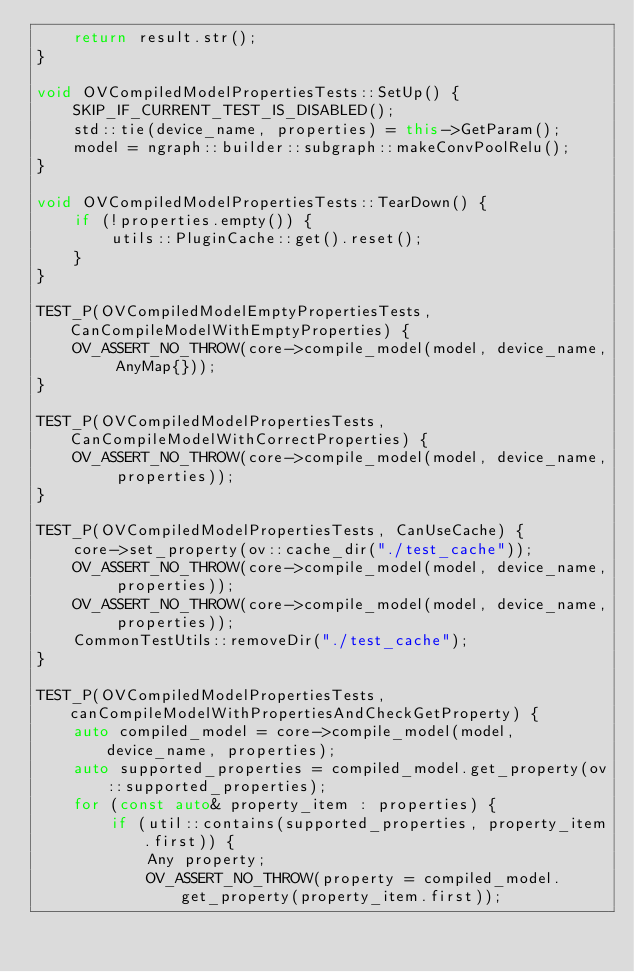Convert code to text. <code><loc_0><loc_0><loc_500><loc_500><_C++_>    return result.str();
}

void OVCompiledModelPropertiesTests::SetUp() {
    SKIP_IF_CURRENT_TEST_IS_DISABLED();
    std::tie(device_name, properties) = this->GetParam();
    model = ngraph::builder::subgraph::makeConvPoolRelu();
}

void OVCompiledModelPropertiesTests::TearDown() {
    if (!properties.empty()) {
        utils::PluginCache::get().reset();
    }
}

TEST_P(OVCompiledModelEmptyPropertiesTests, CanCompileModelWithEmptyProperties) {
    OV_ASSERT_NO_THROW(core->compile_model(model, device_name, AnyMap{}));
}

TEST_P(OVCompiledModelPropertiesTests, CanCompileModelWithCorrectProperties) {
    OV_ASSERT_NO_THROW(core->compile_model(model, device_name, properties));
}

TEST_P(OVCompiledModelPropertiesTests, CanUseCache) {
    core->set_property(ov::cache_dir("./test_cache"));
    OV_ASSERT_NO_THROW(core->compile_model(model, device_name, properties));
    OV_ASSERT_NO_THROW(core->compile_model(model, device_name, properties));
    CommonTestUtils::removeDir("./test_cache");
}

TEST_P(OVCompiledModelPropertiesTests, canCompileModelWithPropertiesAndCheckGetProperty) {
    auto compiled_model = core->compile_model(model, device_name, properties);
    auto supported_properties = compiled_model.get_property(ov::supported_properties);
    for (const auto& property_item : properties) {
        if (util::contains(supported_properties, property_item.first)) {
            Any property;
            OV_ASSERT_NO_THROW(property = compiled_model.get_property(property_item.first));</code> 